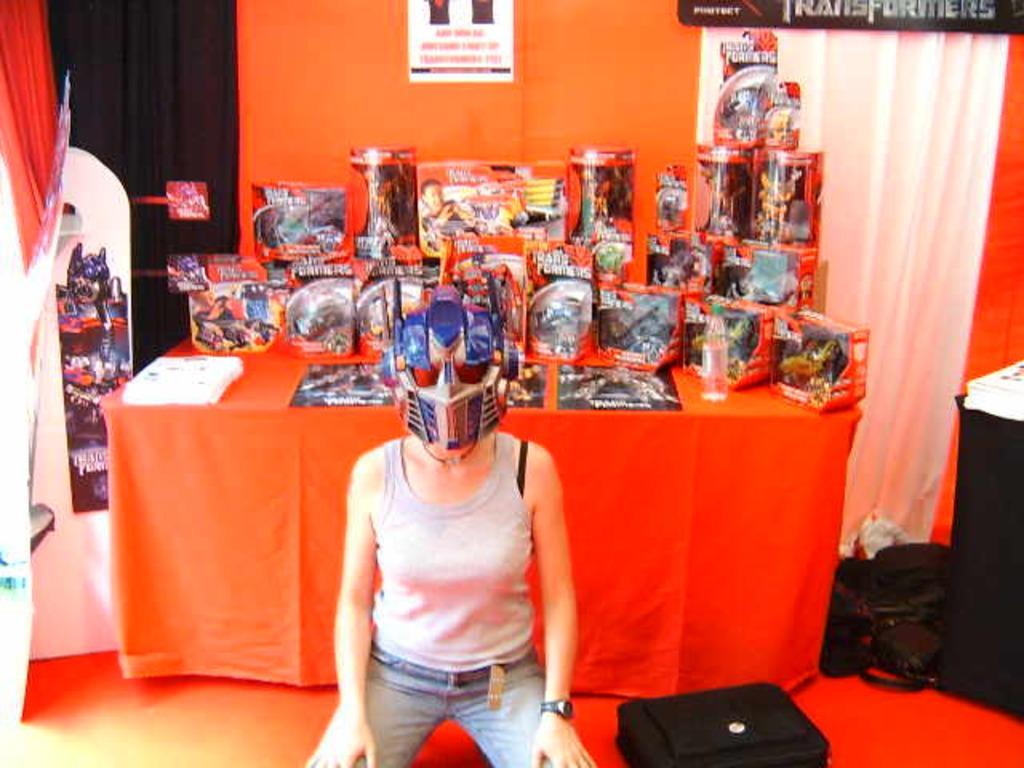In one or two sentences, can you explain what this image depicts? In this image we can see a woman and she wore a helmet kind of object on her head. In the background there are toys and papers on a table, curtains and hoardings. There are bags on the floor on the right side. 